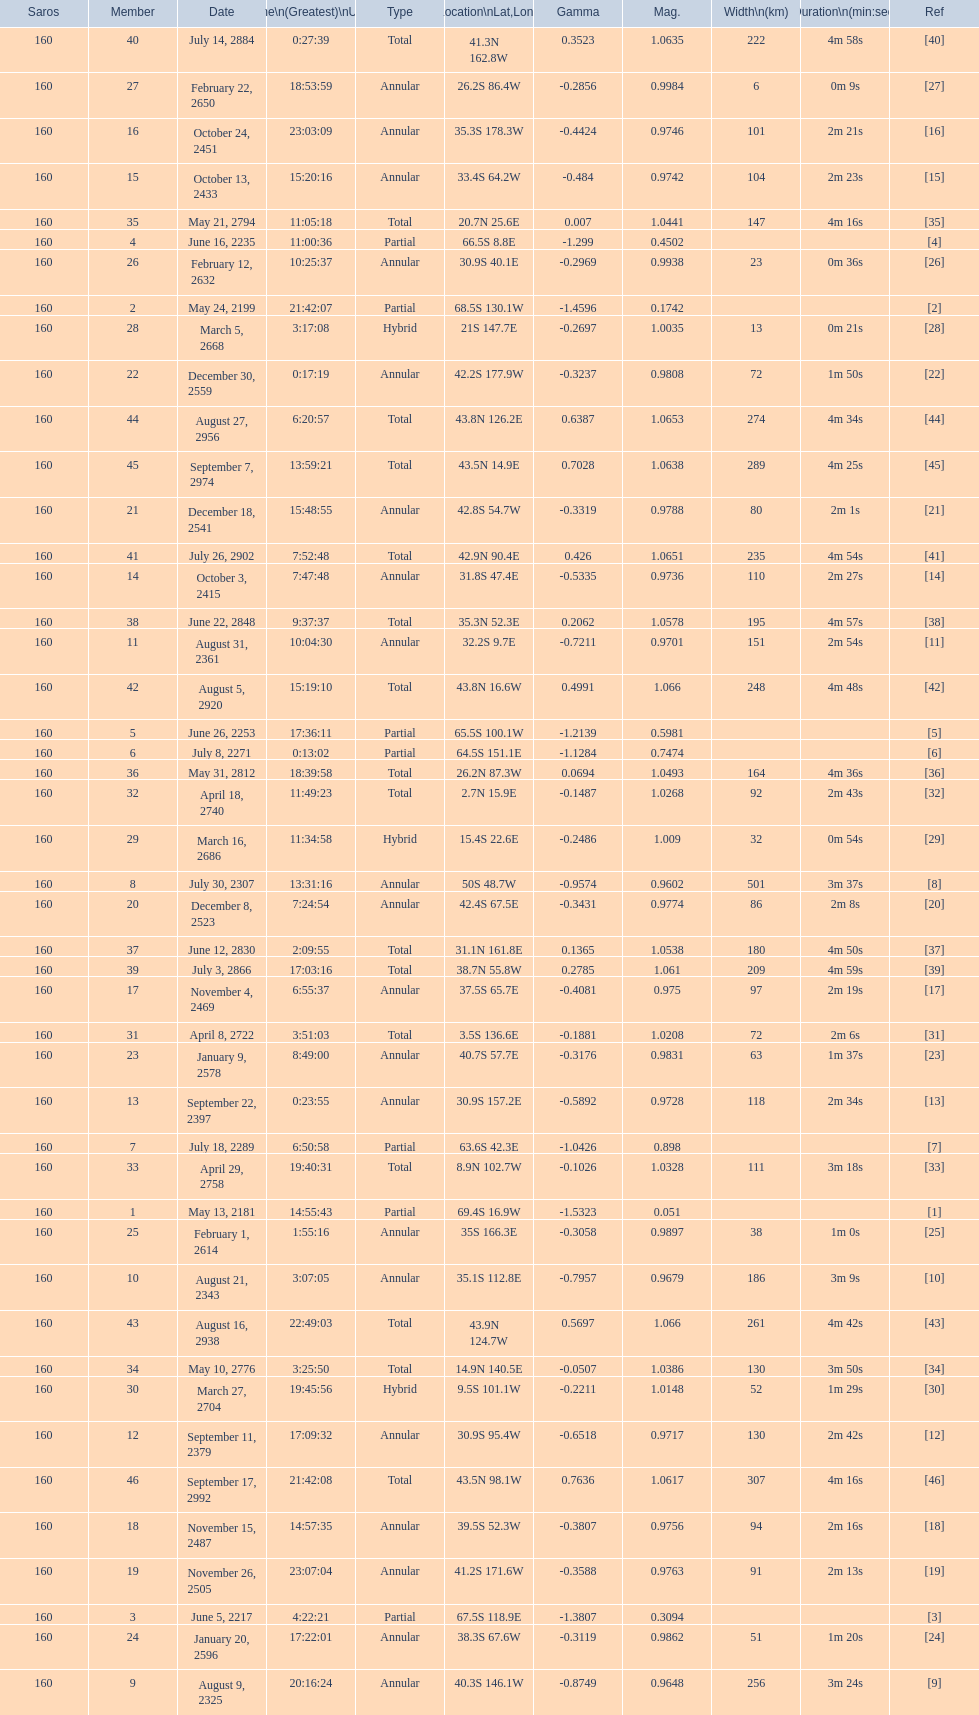What is the difference in magnitude between the may 13, 2181 solar saros and the may 24, 2199 solar saros? 0.1232. 